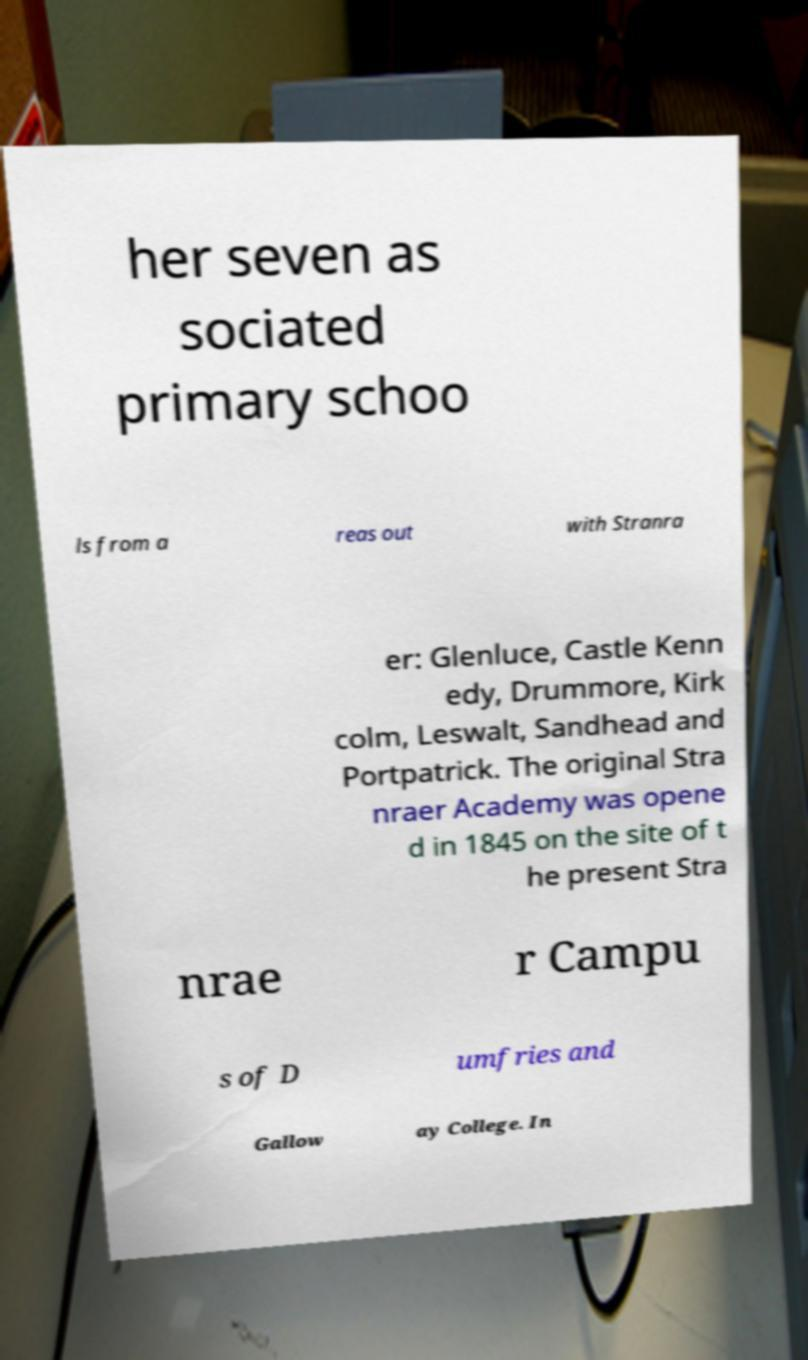Please identify and transcribe the text found in this image. her seven as sociated primary schoo ls from a reas out with Stranra er: Glenluce, Castle Kenn edy, Drummore, Kirk colm, Leswalt, Sandhead and Portpatrick. The original Stra nraer Academy was opene d in 1845 on the site of t he present Stra nrae r Campu s of D umfries and Gallow ay College. In 